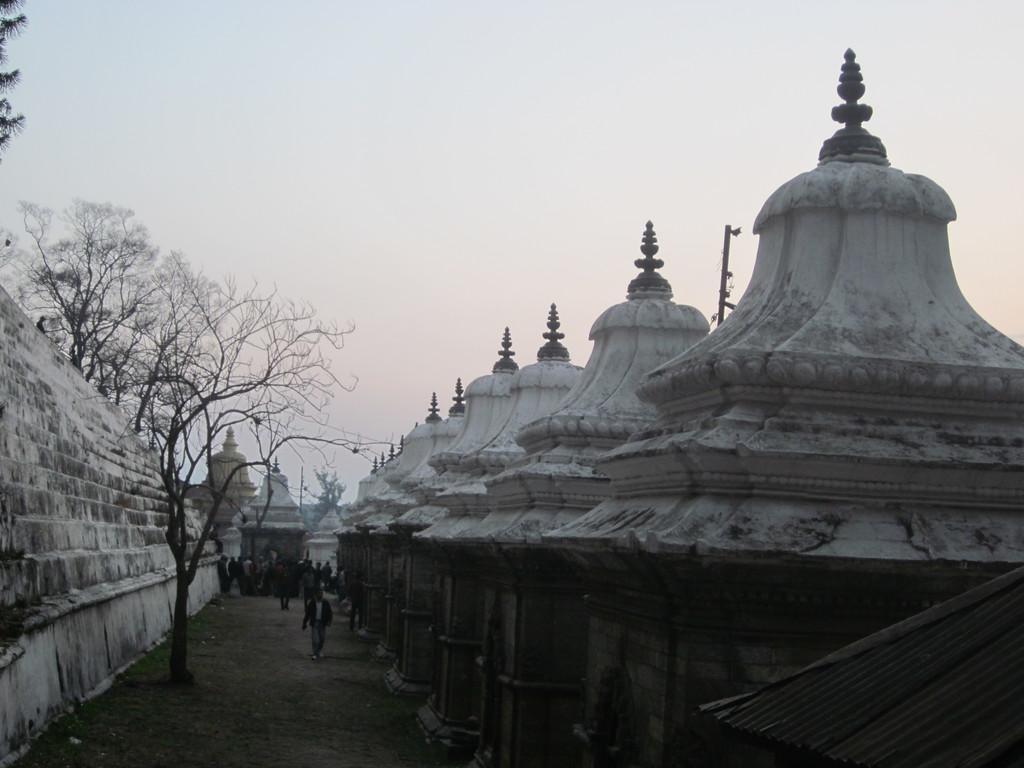Can you describe this image briefly? In this image we can see buildings, persons walking on the ground, trees and sky. 